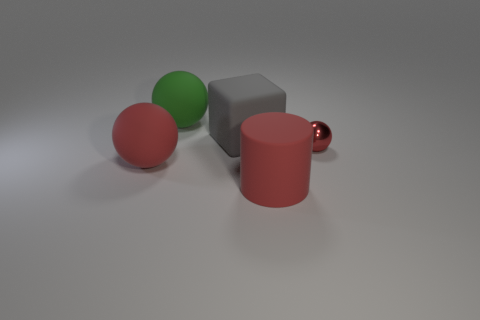Add 2 red objects. How many objects exist? 7 Subtract all big green rubber balls. How many balls are left? 2 Subtract all green balls. How many balls are left? 2 Subtract 1 spheres. How many spheres are left? 2 Subtract all cyan balls. How many blue cubes are left? 0 Add 2 big green rubber objects. How many big green rubber objects exist? 3 Subtract 0 gray cylinders. How many objects are left? 5 Subtract all cubes. How many objects are left? 4 Subtract all brown cubes. Subtract all gray spheres. How many cubes are left? 1 Subtract all big red balls. Subtract all big green things. How many objects are left? 3 